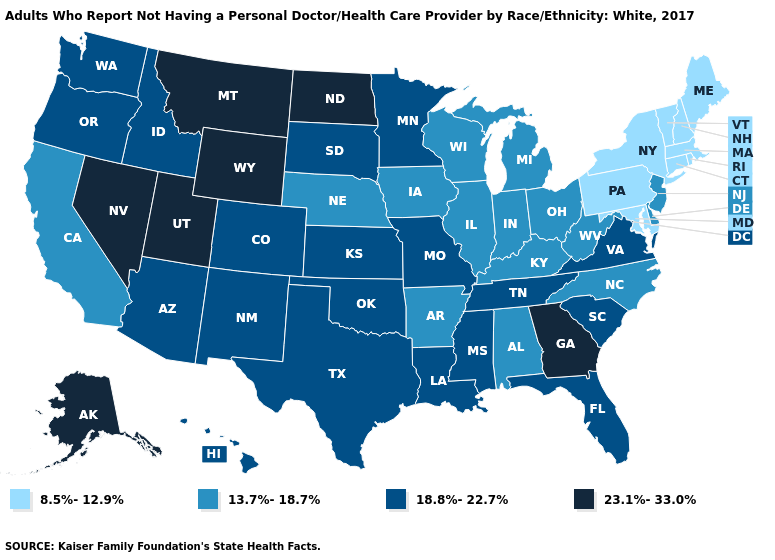What is the value of Massachusetts?
Be succinct. 8.5%-12.9%. Does Illinois have the lowest value in the MidWest?
Answer briefly. Yes. What is the value of Missouri?
Give a very brief answer. 18.8%-22.7%. Does Maine have the same value as Maryland?
Short answer required. Yes. What is the value of Mississippi?
Write a very short answer. 18.8%-22.7%. Does North Dakota have the highest value in the USA?
Concise answer only. Yes. Which states have the lowest value in the MidWest?
Write a very short answer. Illinois, Indiana, Iowa, Michigan, Nebraska, Ohio, Wisconsin. What is the value of Hawaii?
Concise answer only. 18.8%-22.7%. What is the value of New Jersey?
Answer briefly. 13.7%-18.7%. Which states have the highest value in the USA?
Short answer required. Alaska, Georgia, Montana, Nevada, North Dakota, Utah, Wyoming. Name the states that have a value in the range 18.8%-22.7%?
Keep it brief. Arizona, Colorado, Florida, Hawaii, Idaho, Kansas, Louisiana, Minnesota, Mississippi, Missouri, New Mexico, Oklahoma, Oregon, South Carolina, South Dakota, Tennessee, Texas, Virginia, Washington. What is the highest value in states that border South Dakota?
Concise answer only. 23.1%-33.0%. What is the value of Utah?
Give a very brief answer. 23.1%-33.0%. How many symbols are there in the legend?
Quick response, please. 4. 